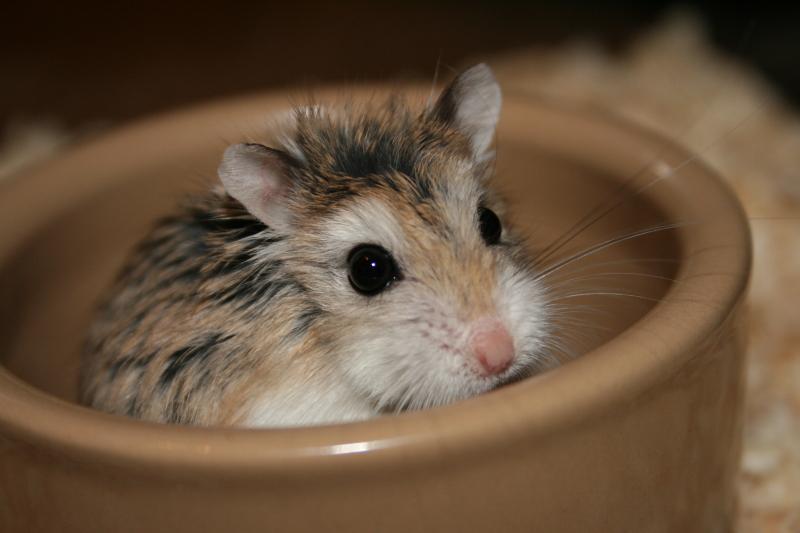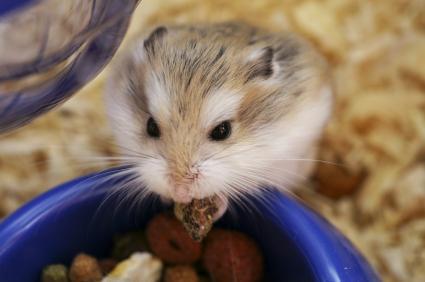The first image is the image on the left, the second image is the image on the right. Given the left and right images, does the statement "The hamster in the left image is inside a bowl, and the hamster on the right is next to a bowl filled with pet food." hold true? Answer yes or no. Yes. The first image is the image on the left, the second image is the image on the right. Analyze the images presented: Is the assertion "In the image on the left an animal is sitting in a bowl." valid? Answer yes or no. Yes. 